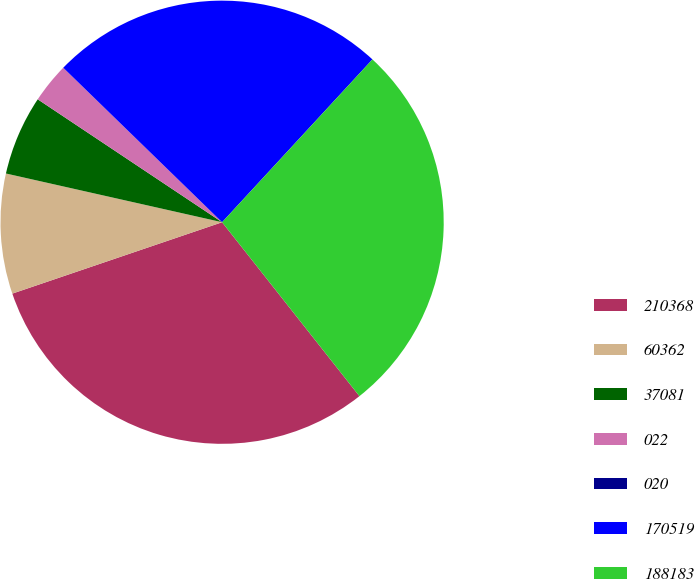Convert chart to OTSL. <chart><loc_0><loc_0><loc_500><loc_500><pie_chart><fcel>210368<fcel>60362<fcel>37081<fcel>022<fcel>020<fcel>170519<fcel>188183<nl><fcel>30.42%<fcel>8.75%<fcel>5.83%<fcel>2.92%<fcel>0.0%<fcel>24.59%<fcel>27.5%<nl></chart> 